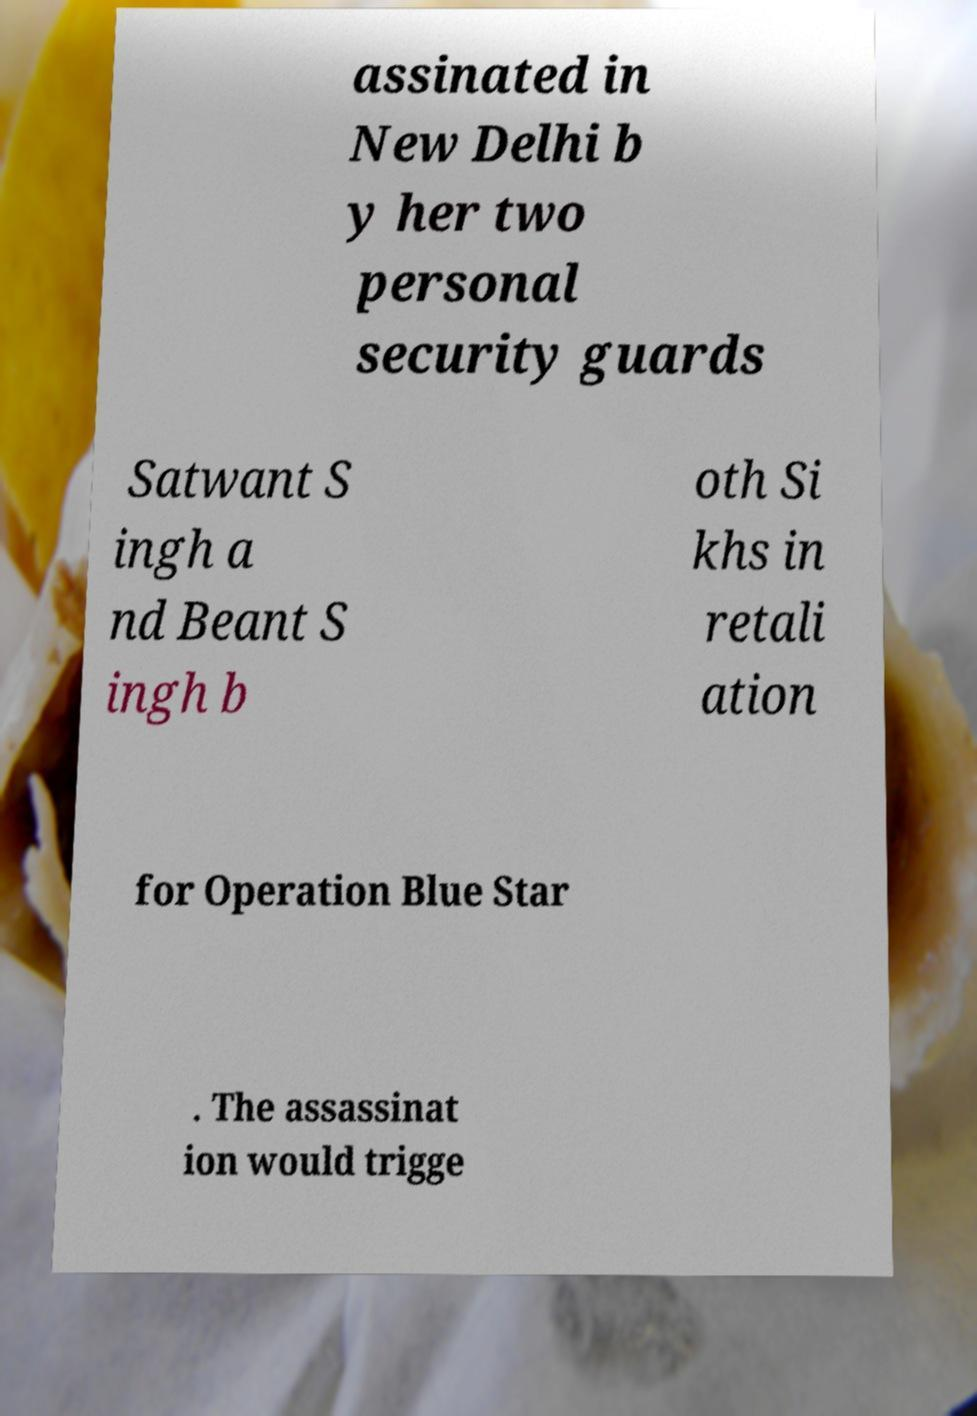Can you read and provide the text displayed in the image?This photo seems to have some interesting text. Can you extract and type it out for me? assinated in New Delhi b y her two personal security guards Satwant S ingh a nd Beant S ingh b oth Si khs in retali ation for Operation Blue Star . The assassinat ion would trigge 